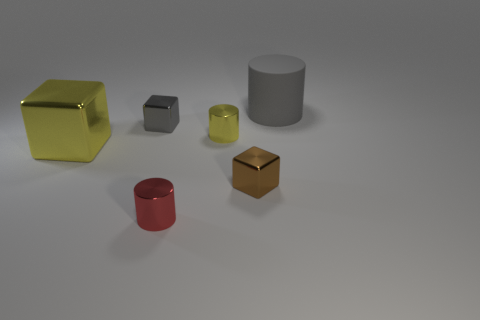Do the shapes of the objects have any particular significance? The objects' shapes—a cube, a cylinder, and variations thereof—may symbolize fundamental geometric forms, often used as the building blocks of more complex designs. Their simple yet distinct forms allow for an examination of spatial relationships and could serve educational purposes in understanding volume, area, and the effects of perspective in a three-dimensional space. 